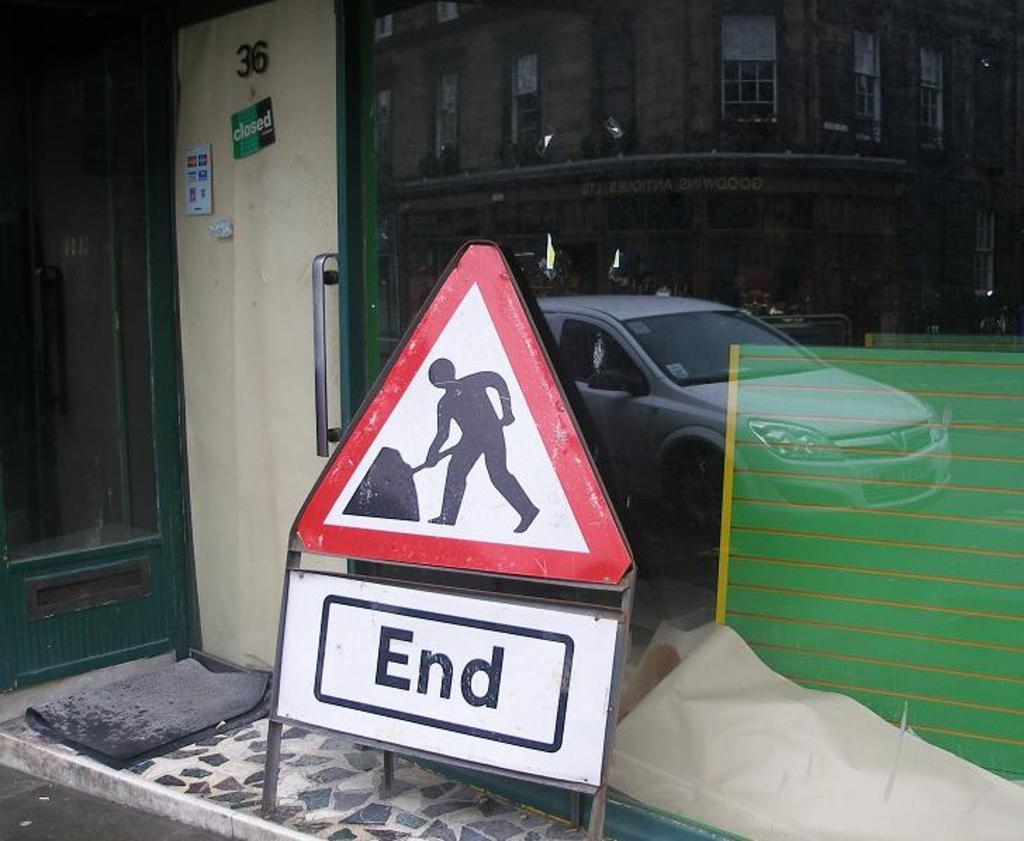<image>
Give a short and clear explanation of the subsequent image. A sign featuring a man working says End under it. 